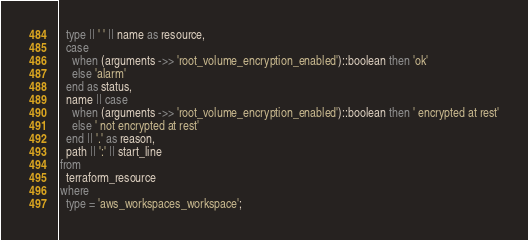<code> <loc_0><loc_0><loc_500><loc_500><_SQL_>  type || ' ' || name as resource,
  case
    when (arguments ->> 'root_volume_encryption_enabled')::boolean then 'ok'
    else 'alarm'
  end as status,
  name || case
    when (arguments ->> 'root_volume_encryption_enabled')::boolean then ' encrypted at rest'
    else ' not encrypted at rest'
  end || '.' as reason,
  path || ':' || start_line
from
  terraform_resource
where
  type = 'aws_workspaces_workspace';</code> 